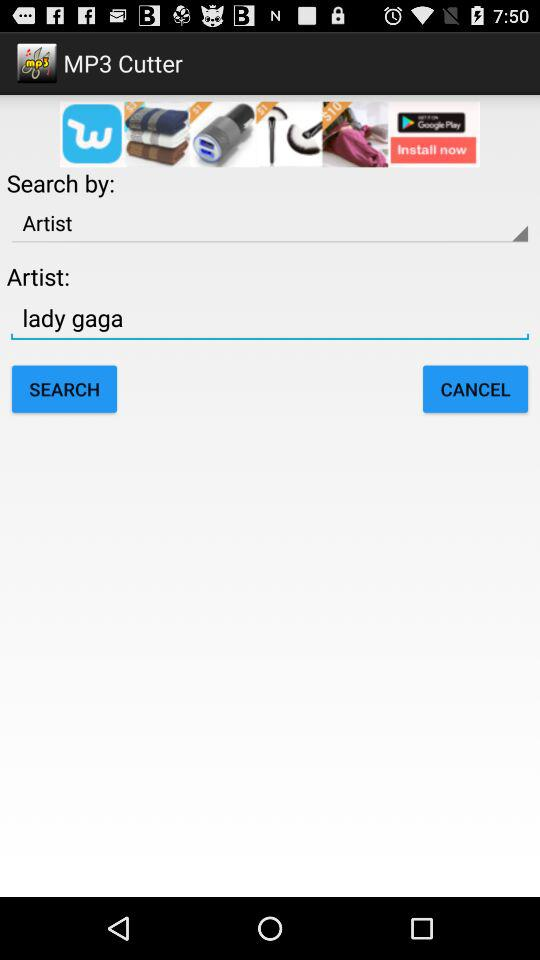Which artist has been chosen? The artist that has been chosen is Lady Gaga. 